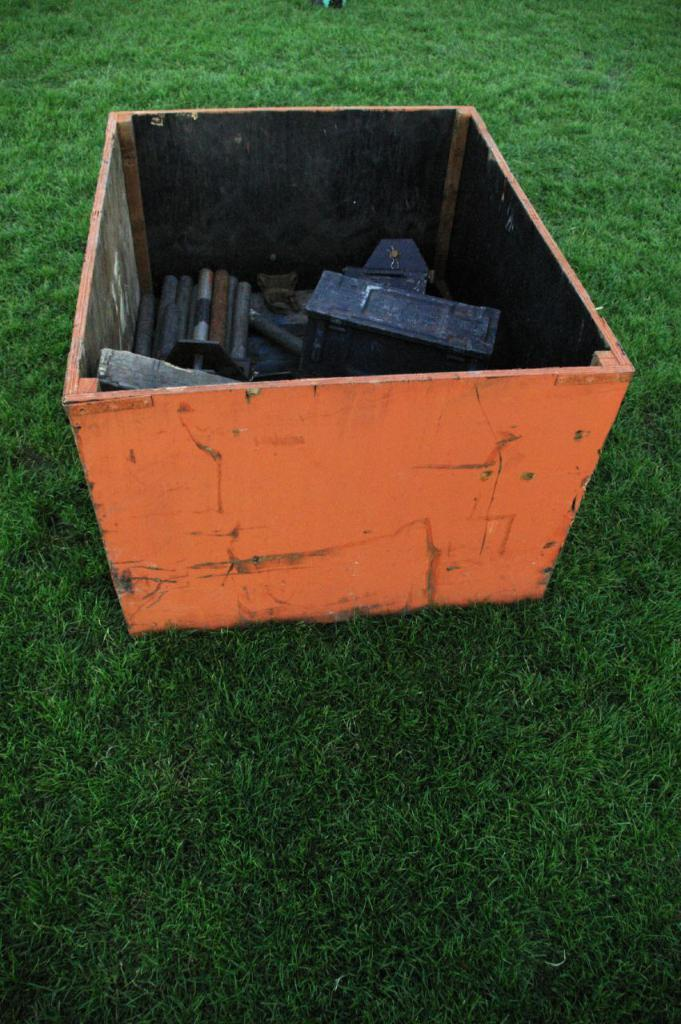What color is the box that is visible in the image? There is an orange color box in the image. Where is the box located in the image? The box is on the ground. What might be inside the box based on the information provided? There are objects inside the box. What type of honey can be seen dripping from the chain in the image? There is no honey or chain present in the image. 